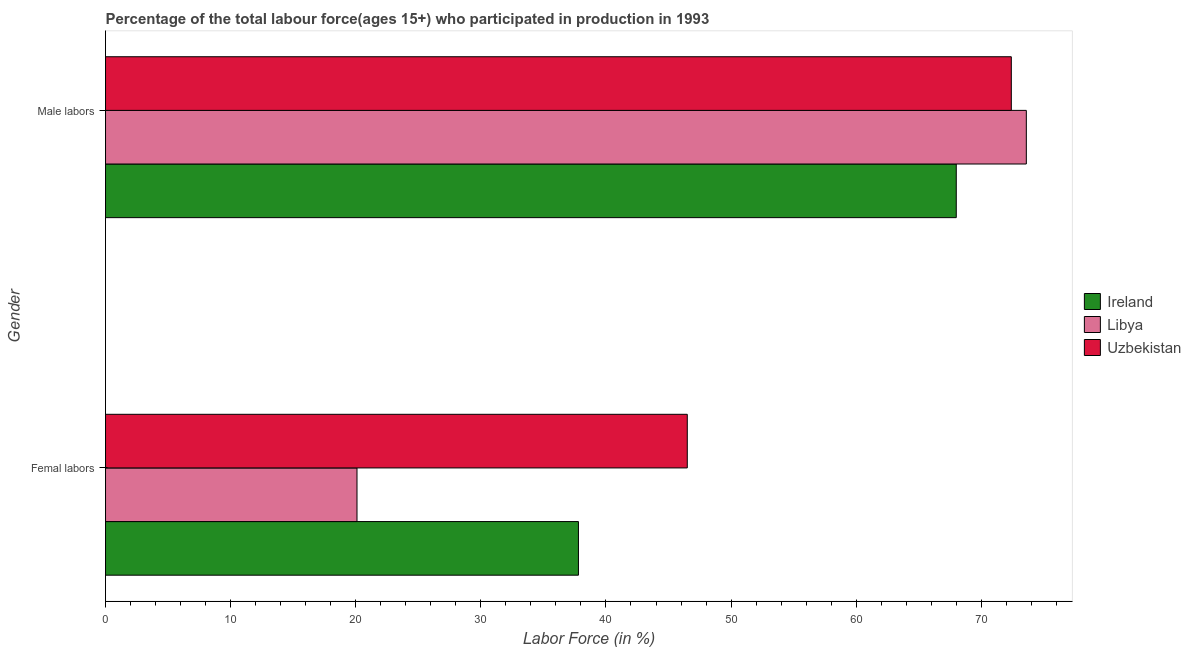How many groups of bars are there?
Ensure brevity in your answer.  2. How many bars are there on the 2nd tick from the top?
Offer a terse response. 3. How many bars are there on the 1st tick from the bottom?
Keep it short and to the point. 3. What is the label of the 1st group of bars from the top?
Your answer should be compact. Male labors. What is the percentage of male labour force in Libya?
Give a very brief answer. 73.6. Across all countries, what is the maximum percentage of female labor force?
Make the answer very short. 46.5. Across all countries, what is the minimum percentage of female labor force?
Keep it short and to the point. 20.1. In which country was the percentage of male labour force maximum?
Your response must be concise. Libya. In which country was the percentage of female labor force minimum?
Make the answer very short. Libya. What is the total percentage of female labor force in the graph?
Provide a short and direct response. 104.4. What is the difference between the percentage of female labor force in Uzbekistan and that in Libya?
Your response must be concise. 26.4. What is the difference between the percentage of male labour force in Ireland and the percentage of female labor force in Uzbekistan?
Offer a very short reply. 21.5. What is the average percentage of male labour force per country?
Your response must be concise. 71.33. What is the difference between the percentage of male labour force and percentage of female labor force in Ireland?
Give a very brief answer. 30.2. What is the ratio of the percentage of female labor force in Uzbekistan to that in Libya?
Your response must be concise. 2.31. In how many countries, is the percentage of female labor force greater than the average percentage of female labor force taken over all countries?
Ensure brevity in your answer.  2. What does the 3rd bar from the top in Femal labors represents?
Provide a succinct answer. Ireland. What does the 1st bar from the bottom in Male labors represents?
Make the answer very short. Ireland. How many bars are there?
Provide a short and direct response. 6. How many countries are there in the graph?
Give a very brief answer. 3. What is the difference between two consecutive major ticks on the X-axis?
Make the answer very short. 10. Are the values on the major ticks of X-axis written in scientific E-notation?
Provide a short and direct response. No. Does the graph contain any zero values?
Your answer should be very brief. No. How many legend labels are there?
Offer a terse response. 3. How are the legend labels stacked?
Ensure brevity in your answer.  Vertical. What is the title of the graph?
Your answer should be compact. Percentage of the total labour force(ages 15+) who participated in production in 1993. Does "Sint Maarten (Dutch part)" appear as one of the legend labels in the graph?
Provide a short and direct response. No. What is the label or title of the Y-axis?
Your response must be concise. Gender. What is the Labor Force (in %) of Ireland in Femal labors?
Provide a short and direct response. 37.8. What is the Labor Force (in %) in Libya in Femal labors?
Provide a short and direct response. 20.1. What is the Labor Force (in %) of Uzbekistan in Femal labors?
Make the answer very short. 46.5. What is the Labor Force (in %) in Libya in Male labors?
Provide a succinct answer. 73.6. What is the Labor Force (in %) in Uzbekistan in Male labors?
Make the answer very short. 72.4. Across all Gender, what is the maximum Labor Force (in %) of Libya?
Offer a very short reply. 73.6. Across all Gender, what is the maximum Labor Force (in %) of Uzbekistan?
Ensure brevity in your answer.  72.4. Across all Gender, what is the minimum Labor Force (in %) in Ireland?
Ensure brevity in your answer.  37.8. Across all Gender, what is the minimum Labor Force (in %) of Libya?
Your response must be concise. 20.1. Across all Gender, what is the minimum Labor Force (in %) in Uzbekistan?
Make the answer very short. 46.5. What is the total Labor Force (in %) in Ireland in the graph?
Your answer should be very brief. 105.8. What is the total Labor Force (in %) of Libya in the graph?
Your response must be concise. 93.7. What is the total Labor Force (in %) of Uzbekistan in the graph?
Ensure brevity in your answer.  118.9. What is the difference between the Labor Force (in %) in Ireland in Femal labors and that in Male labors?
Your response must be concise. -30.2. What is the difference between the Labor Force (in %) of Libya in Femal labors and that in Male labors?
Keep it short and to the point. -53.5. What is the difference between the Labor Force (in %) in Uzbekistan in Femal labors and that in Male labors?
Offer a very short reply. -25.9. What is the difference between the Labor Force (in %) in Ireland in Femal labors and the Labor Force (in %) in Libya in Male labors?
Keep it short and to the point. -35.8. What is the difference between the Labor Force (in %) of Ireland in Femal labors and the Labor Force (in %) of Uzbekistan in Male labors?
Your response must be concise. -34.6. What is the difference between the Labor Force (in %) of Libya in Femal labors and the Labor Force (in %) of Uzbekistan in Male labors?
Ensure brevity in your answer.  -52.3. What is the average Labor Force (in %) of Ireland per Gender?
Your answer should be very brief. 52.9. What is the average Labor Force (in %) in Libya per Gender?
Ensure brevity in your answer.  46.85. What is the average Labor Force (in %) of Uzbekistan per Gender?
Your response must be concise. 59.45. What is the difference between the Labor Force (in %) in Ireland and Labor Force (in %) in Libya in Femal labors?
Provide a succinct answer. 17.7. What is the difference between the Labor Force (in %) in Libya and Labor Force (in %) in Uzbekistan in Femal labors?
Provide a succinct answer. -26.4. What is the ratio of the Labor Force (in %) in Ireland in Femal labors to that in Male labors?
Ensure brevity in your answer.  0.56. What is the ratio of the Labor Force (in %) in Libya in Femal labors to that in Male labors?
Provide a short and direct response. 0.27. What is the ratio of the Labor Force (in %) in Uzbekistan in Femal labors to that in Male labors?
Provide a succinct answer. 0.64. What is the difference between the highest and the second highest Labor Force (in %) in Ireland?
Ensure brevity in your answer.  30.2. What is the difference between the highest and the second highest Labor Force (in %) in Libya?
Ensure brevity in your answer.  53.5. What is the difference between the highest and the second highest Labor Force (in %) of Uzbekistan?
Provide a short and direct response. 25.9. What is the difference between the highest and the lowest Labor Force (in %) in Ireland?
Offer a very short reply. 30.2. What is the difference between the highest and the lowest Labor Force (in %) of Libya?
Make the answer very short. 53.5. What is the difference between the highest and the lowest Labor Force (in %) of Uzbekistan?
Make the answer very short. 25.9. 